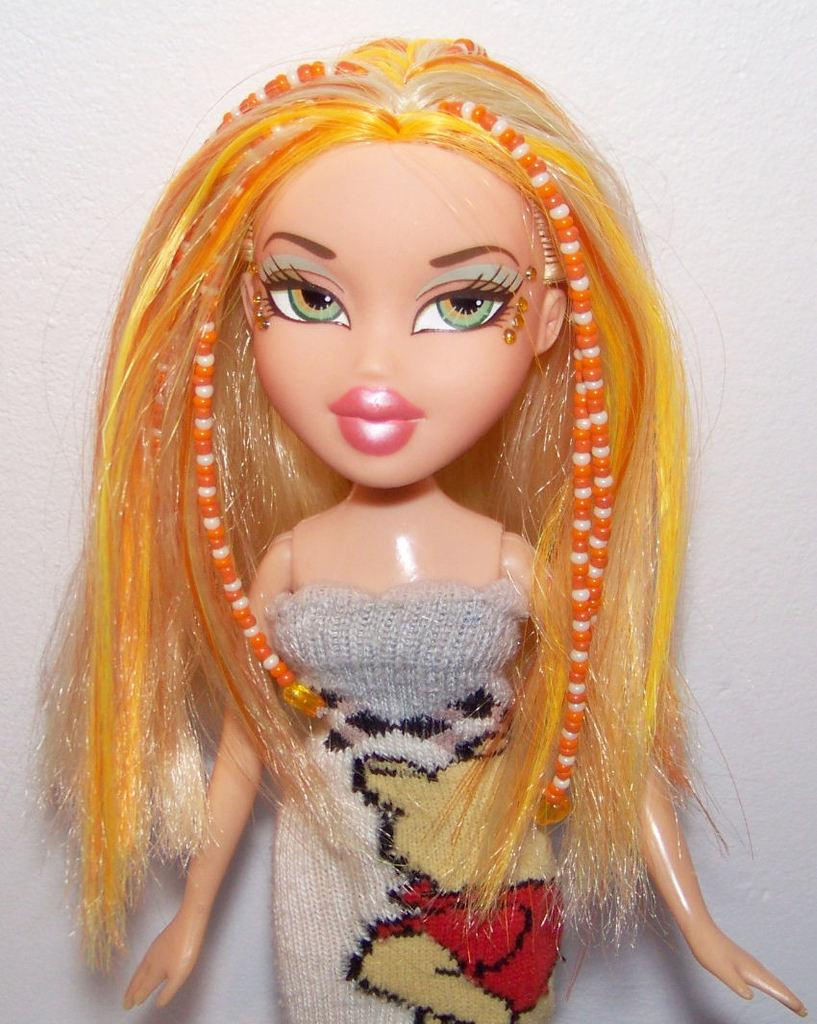What is the main subject in the center of the image? There is a doll in the center of the image. What can be seen in the background of the image? There is a wall in the background of the image. Reasoning: Let's think step by step by step in order to produce the conversation. We start by identifying the main subject in the image, which is the doll. Then, we expand the conversation to include the background of the image, which features a wall. Each question is designed to elicit a specific detail about the image that is known from the provided facts. Absurd Question/Answer: What type of pets can be seen playing with the doll in the image? There are no pets present in the image, and the doll is not being played with. 